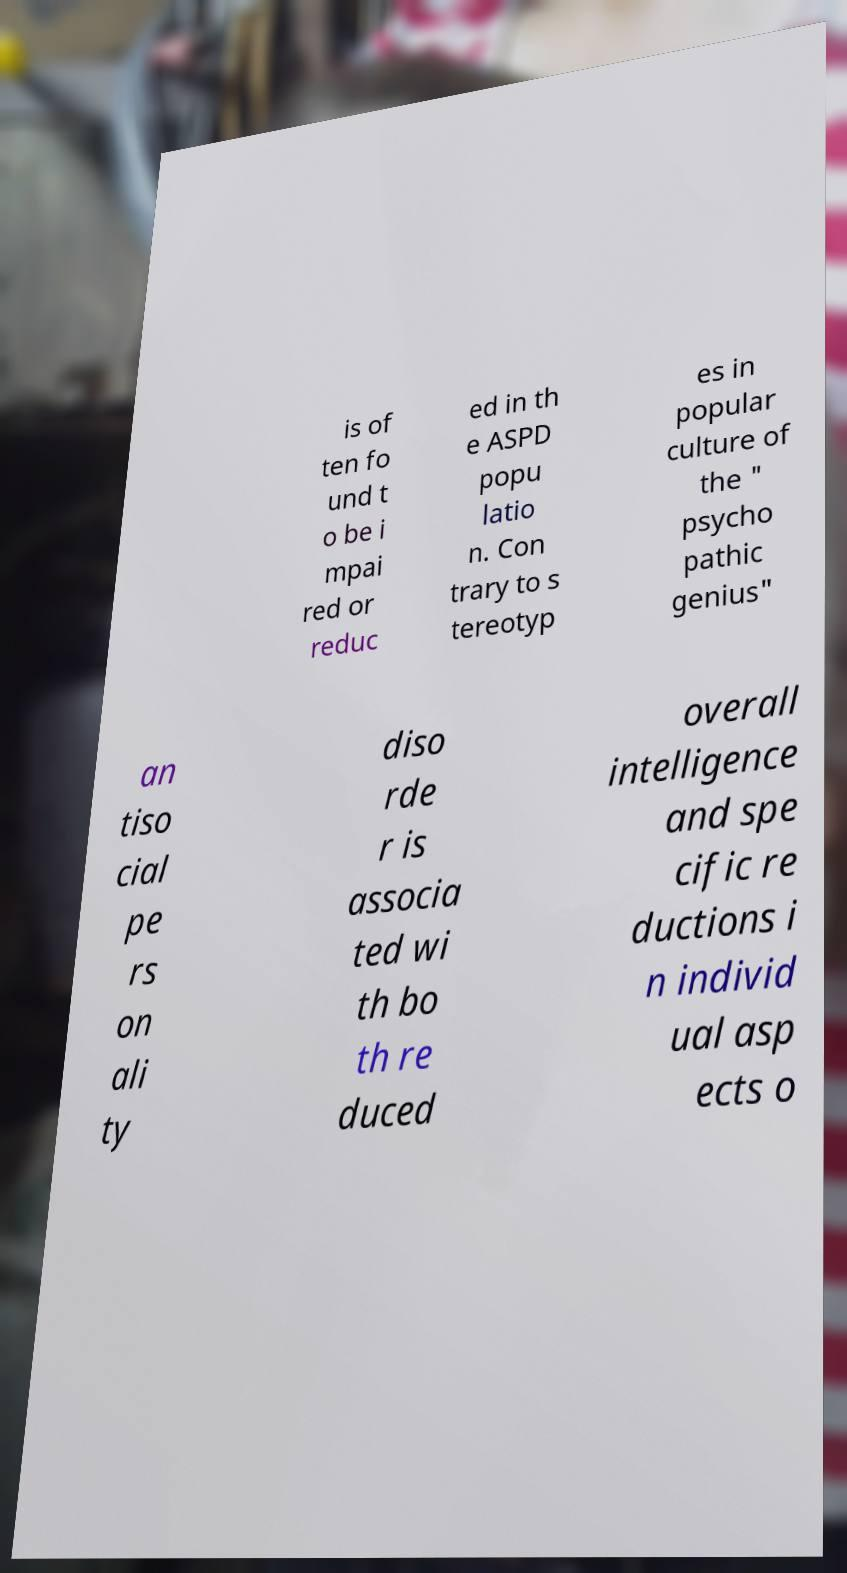Please identify and transcribe the text found in this image. is of ten fo und t o be i mpai red or reduc ed in th e ASPD popu latio n. Con trary to s tereotyp es in popular culture of the " psycho pathic genius" an tiso cial pe rs on ali ty diso rde r is associa ted wi th bo th re duced overall intelligence and spe cific re ductions i n individ ual asp ects o 